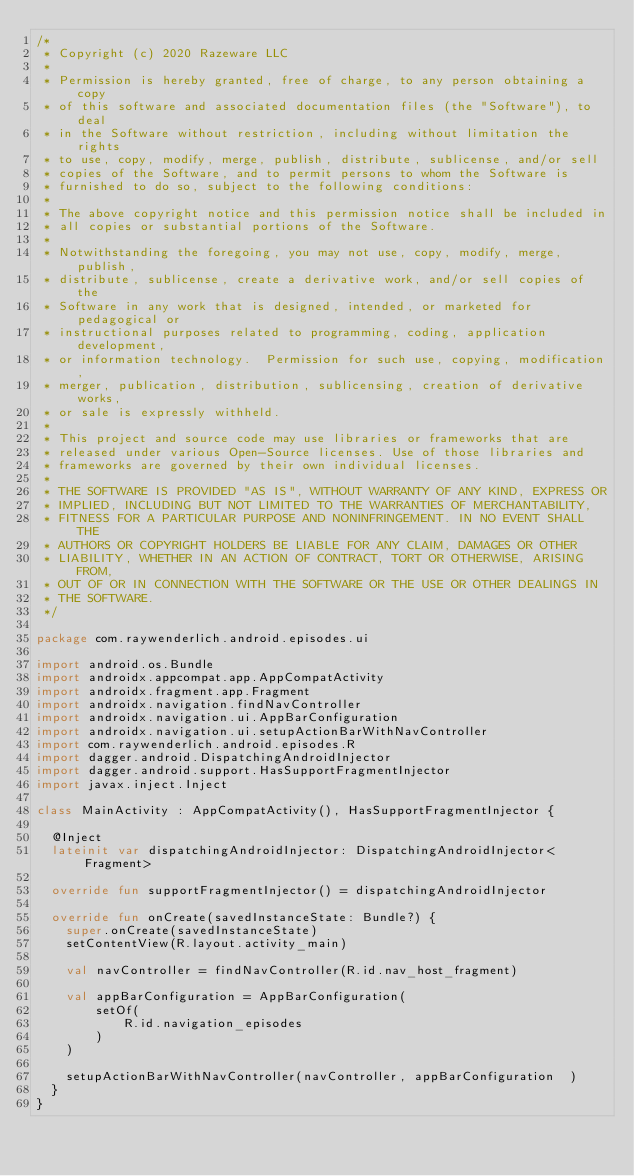Convert code to text. <code><loc_0><loc_0><loc_500><loc_500><_Kotlin_>/* 
 * Copyright (c) 2020 Razeware LLC
 * 
 * Permission is hereby granted, free of charge, to any person obtaining a copy
 * of this software and associated documentation files (the "Software"), to deal
 * in the Software without restriction, including without limitation the rights
 * to use, copy, modify, merge, publish, distribute, sublicense, and/or sell
 * copies of the Software, and to permit persons to whom the Software is
 * furnished to do so, subject to the following conditions:
 * 
 * The above copyright notice and this permission notice shall be included in
 * all copies or substantial portions of the Software.
 * 
 * Notwithstanding the foregoing, you may not use, copy, modify, merge, publish,
 * distribute, sublicense, create a derivative work, and/or sell copies of the
 * Software in any work that is designed, intended, or marketed for pedagogical or
 * instructional purposes related to programming, coding, application development,
 * or information technology.  Permission for such use, copying, modification,
 * merger, publication, distribution, sublicensing, creation of derivative works,
 * or sale is expressly withheld.
 * 
 * This project and source code may use libraries or frameworks that are
 * released under various Open-Source licenses. Use of those libraries and
 * frameworks are governed by their own individual licenses.
 * 
 * THE SOFTWARE IS PROVIDED "AS IS", WITHOUT WARRANTY OF ANY KIND, EXPRESS OR
 * IMPLIED, INCLUDING BUT NOT LIMITED TO THE WARRANTIES OF MERCHANTABILITY,
 * FITNESS FOR A PARTICULAR PURPOSE AND NONINFRINGEMENT. IN NO EVENT SHALL THE
 * AUTHORS OR COPYRIGHT HOLDERS BE LIABLE FOR ANY CLAIM, DAMAGES OR OTHER
 * LIABILITY, WHETHER IN AN ACTION OF CONTRACT, TORT OR OTHERWISE, ARISING FROM,
 * OUT OF OR IN CONNECTION WITH THE SOFTWARE OR THE USE OR OTHER DEALINGS IN
 * THE SOFTWARE.
 */

package com.raywenderlich.android.episodes.ui

import android.os.Bundle
import androidx.appcompat.app.AppCompatActivity
import androidx.fragment.app.Fragment
import androidx.navigation.findNavController
import androidx.navigation.ui.AppBarConfiguration
import androidx.navigation.ui.setupActionBarWithNavController
import com.raywenderlich.android.episodes.R
import dagger.android.DispatchingAndroidInjector
import dagger.android.support.HasSupportFragmentInjector
import javax.inject.Inject

class MainActivity : AppCompatActivity(), HasSupportFragmentInjector {

  @Inject
  lateinit var dispatchingAndroidInjector: DispatchingAndroidInjector<Fragment>

  override fun supportFragmentInjector() = dispatchingAndroidInjector

  override fun onCreate(savedInstanceState: Bundle?) {
    super.onCreate(savedInstanceState)
    setContentView(R.layout.activity_main)

    val navController = findNavController(R.id.nav_host_fragment)

    val appBarConfiguration = AppBarConfiguration(
        setOf(
            R.id.navigation_episodes
        )
    )

    setupActionBarWithNavController(navController, appBarConfiguration  )
  }
}
</code> 